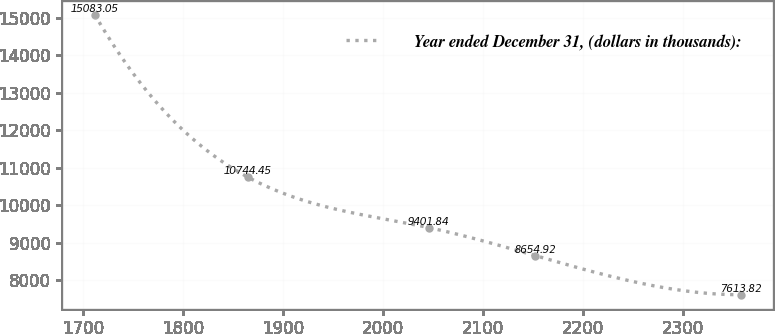Convert chart to OTSL. <chart><loc_0><loc_0><loc_500><loc_500><line_chart><ecel><fcel>Year ended December 31, (dollars in thousands):<nl><fcel>1711.77<fcel>15083<nl><fcel>1865.13<fcel>10744.5<nl><fcel>2045.87<fcel>9401.84<nl><fcel>2152.28<fcel>8654.92<nl><fcel>2358.11<fcel>7613.82<nl></chart> 